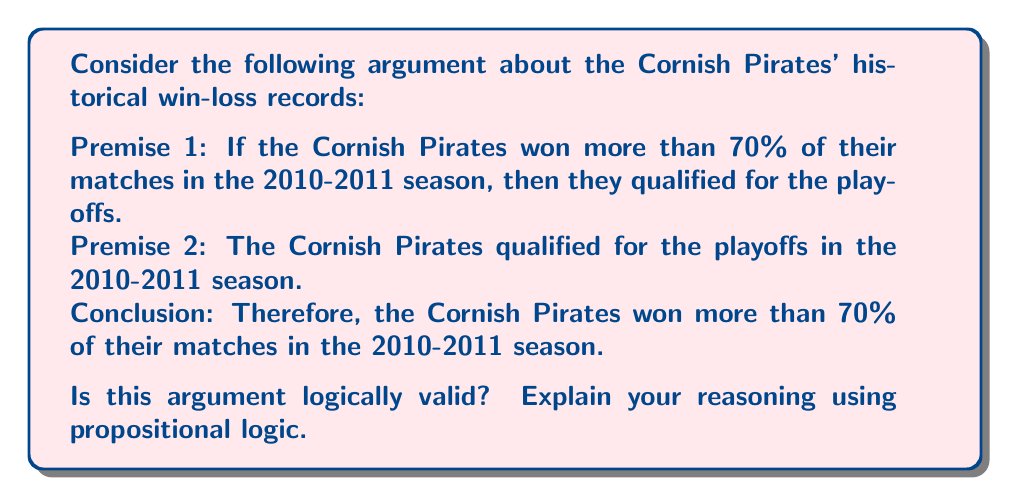Could you help me with this problem? To determine the logical validity of this argument, we need to analyze its structure using propositional logic. Let's define our propositions:

$P$: The Cornish Pirates won more than 70% of their matches in the 2010-2011 season.
$Q$: The Cornish Pirates qualified for the playoffs in the 2010-2011 season.

Now, we can rewrite the argument in symbolic form:

Premise 1: $P \rightarrow Q$
Premise 2: $Q$
Conclusion: $\therefore P$

This argument structure is known as the fallacy of affirming the consequent. To prove that this argument is not logically valid, we can use a truth table to show that it's possible for the premises to be true while the conclusion is false.

$$
\begin{array}{|c|c|c|c|}
\hline
P & Q & P \rightarrow Q & \text{Premises true, Conclusion false?} \\
\hline
T & T & T & \text{No} \\
T & F & F & \text{No} \\
F & T & T & \text{Yes} \\
F & F & T & \text{No} \\
\hline
\end{array}
$$

As we can see from the third row of the truth table, it's possible for both premises to be true $(P \rightarrow Q)$ and $Q$, while the conclusion $P$ is false. This demonstrates that the argument is not logically valid.

In the context of the Cornish Pirates, this means that even if it's true that winning more than 70% of matches guarantees playoff qualification, and the team did qualify for the playoffs, we cannot logically conclude that they necessarily won more than 70% of their matches. There could have been other ways to qualify for the playoffs, or the team might have qualified despite winning less than 70% of their matches.
Answer: The argument is not logically valid. It commits the fallacy of affirming the consequent, which can be demonstrated using a truth table showing that it's possible for the premises to be true while the conclusion is false. 